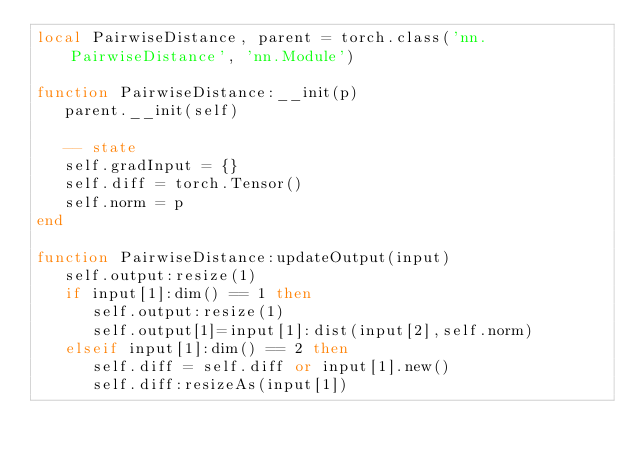<code> <loc_0><loc_0><loc_500><loc_500><_Lua_>local PairwiseDistance, parent = torch.class('nn.PairwiseDistance', 'nn.Module')

function PairwiseDistance:__init(p)
   parent.__init(self)

   -- state
   self.gradInput = {}
   self.diff = torch.Tensor()
   self.norm = p
end 
  
function PairwiseDistance:updateOutput(input)
   self.output:resize(1)
   if input[1]:dim() == 1 then
      self.output:resize(1)
      self.output[1]=input[1]:dist(input[2],self.norm)
   elseif input[1]:dim() == 2 then
      self.diff = self.diff or input[1].new()
      self.diff:resizeAs(input[1])
</code> 